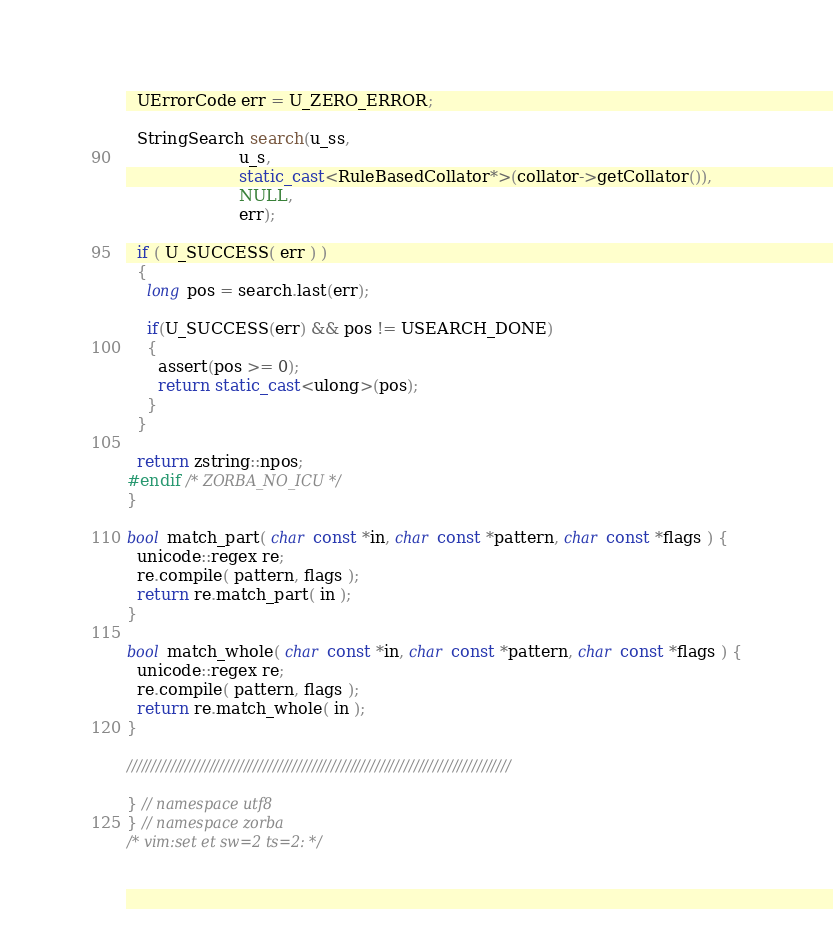<code> <loc_0><loc_0><loc_500><loc_500><_C++_>  UErrorCode err = U_ZERO_ERROR;

  StringSearch search(u_ss,
                      u_s,
                      static_cast<RuleBasedCollator*>(collator->getCollator()),
                      NULL,
                      err);

  if ( U_SUCCESS( err ) ) 
  {
    long pos = search.last(err);

    if(U_SUCCESS(err) && pos != USEARCH_DONE)
    {
      assert(pos >= 0);
      return static_cast<ulong>(pos);
    }
  }

  return zstring::npos;
#endif /* ZORBA_NO_ICU */
}

bool match_part( char const *in, char const *pattern, char const *flags ) {
  unicode::regex re;
  re.compile( pattern, flags );
  return re.match_part( in );
}

bool match_whole( char const *in, char const *pattern, char const *flags ) {
  unicode::regex re;
  re.compile( pattern, flags );
  return re.match_whole( in );
}

///////////////////////////////////////////////////////////////////////////////

} // namespace utf8
} // namespace zorba
/* vim:set et sw=2 ts=2: */
</code> 